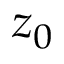Convert formula to latex. <formula><loc_0><loc_0><loc_500><loc_500>z _ { 0 }</formula> 